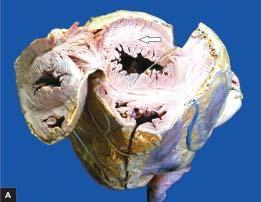s the sequence on left increased?
Answer the question using a single word or phrase. No 